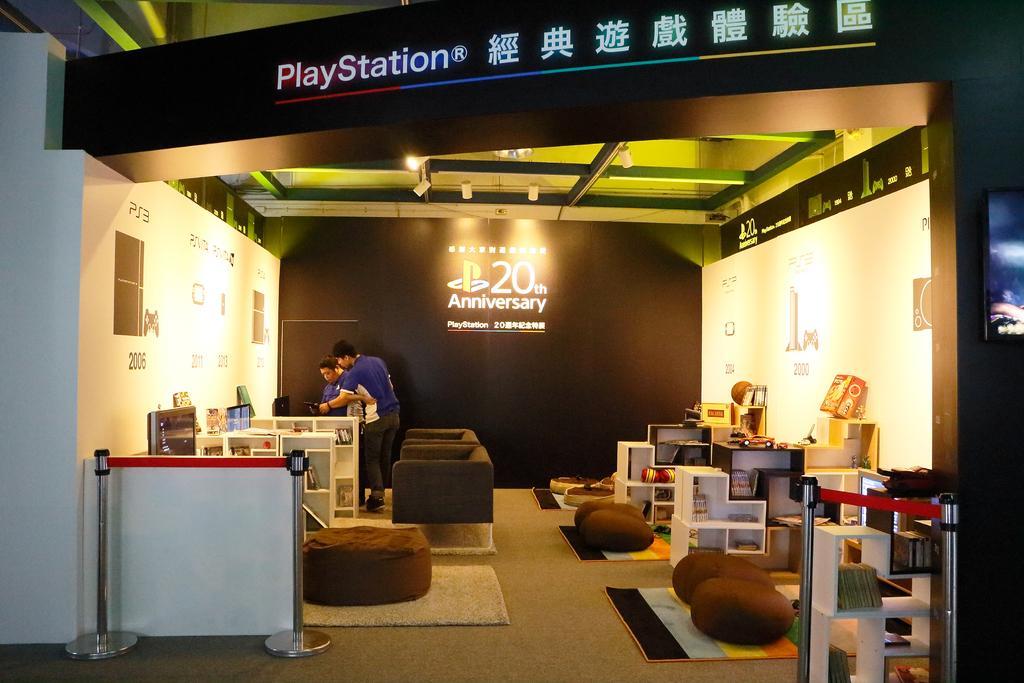Could you give a brief overview of what you see in this image? This image is clicked inside the room. There are two men standing. There are couches and tables. There are racks in the image. There are books and few objects in the image. In the background there are banners. There is text on the banners. There are lights to the ceiling. 